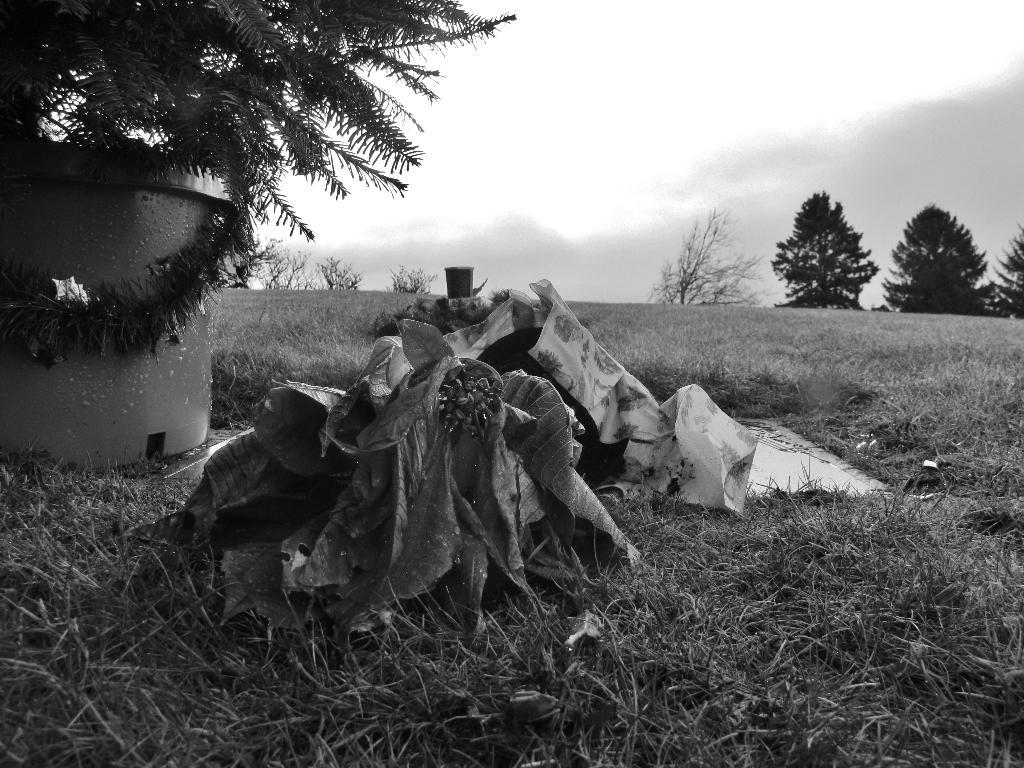What is present on the grass lawn in the image? There is garbage and a plastic cover on the grass lawn. What can be found near the grass lawn? There is a tree near the grass lawn. What type of structure is visible in the image? There is a round concrete tank in the image. What can be seen in the background of the image? There are trees visible in the background. Can you tell me what instrument the tree is playing in the image? There is no instrument present in the image, and trees do not play instruments. Is there a park visible in the image? The image does not show a park; it only shows a grass lawn, a tree, a round concrete tank, and trees in the background. 